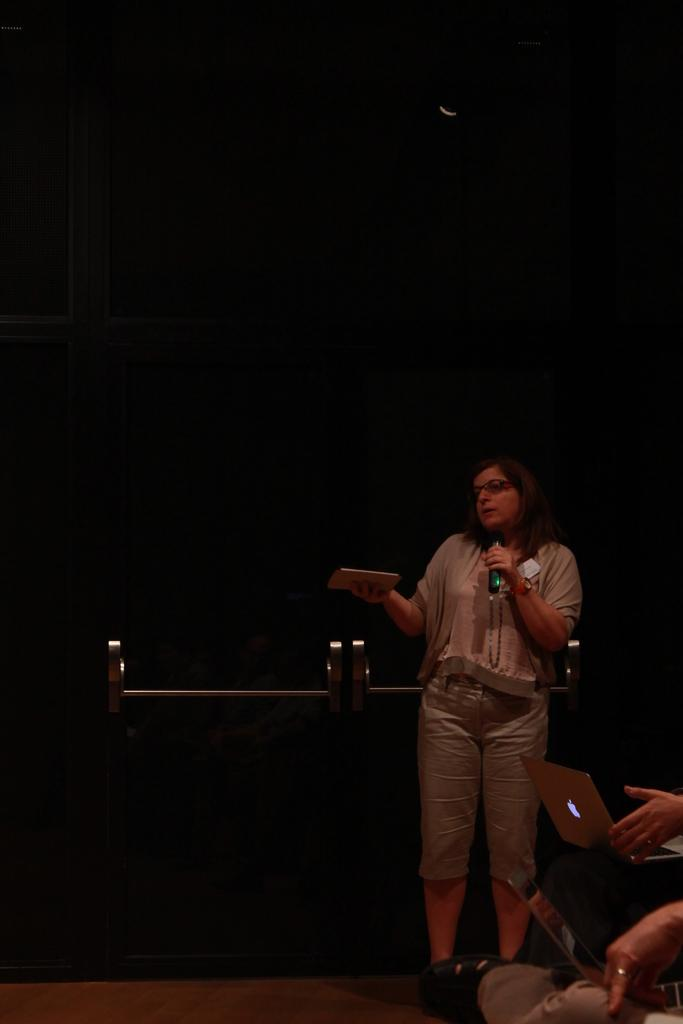What is the woman in the image holding? The woman is holding a microphone and another object. What is the woman's posture in the image? The woman is standing in the image. What are the people in the image using? The people in the image are using laptops. What can be seen on the floor in the image? The floor is visible in the image. What type of objects are present in the image? There are rods in the image. What is the color of the wall in the image? The wall in the image is black. What type of humor can be seen in the image? There is no humor depicted in the image; it shows a woman holding a microphone and an object, people with laptops, and other objects. Is there a stage present in the image? There is no stage visible in the image. 